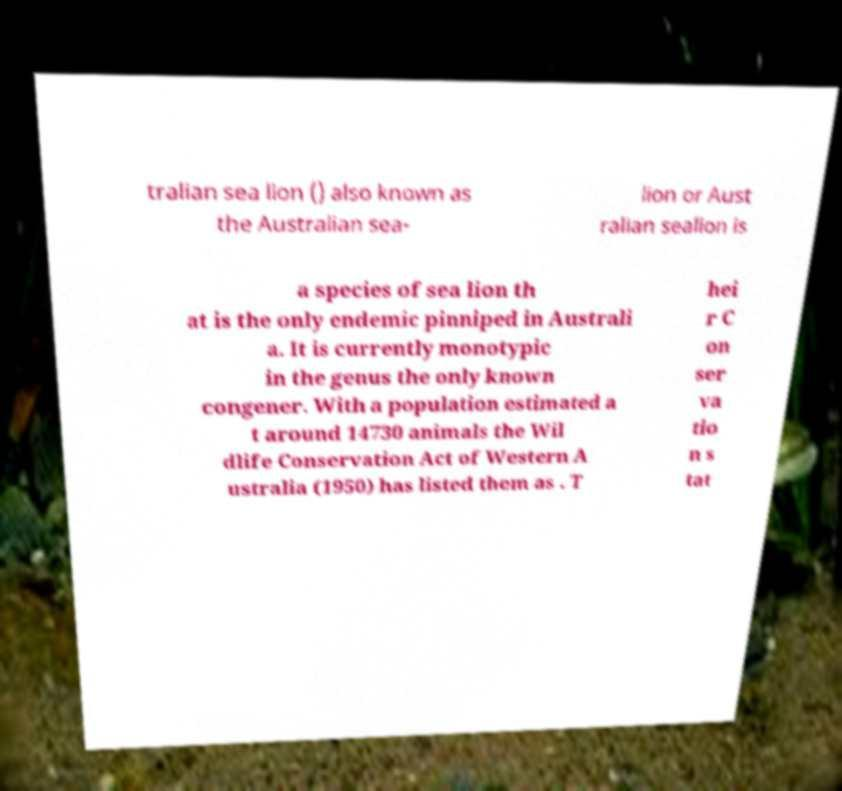What messages or text are displayed in this image? I need them in a readable, typed format. tralian sea lion () also known as the Australian sea- lion or Aust ralian sealion is a species of sea lion th at is the only endemic pinniped in Australi a. It is currently monotypic in the genus the only known congener. With a population estimated a t around 14730 animals the Wil dlife Conservation Act of Western A ustralia (1950) has listed them as . T hei r C on ser va tio n s tat 